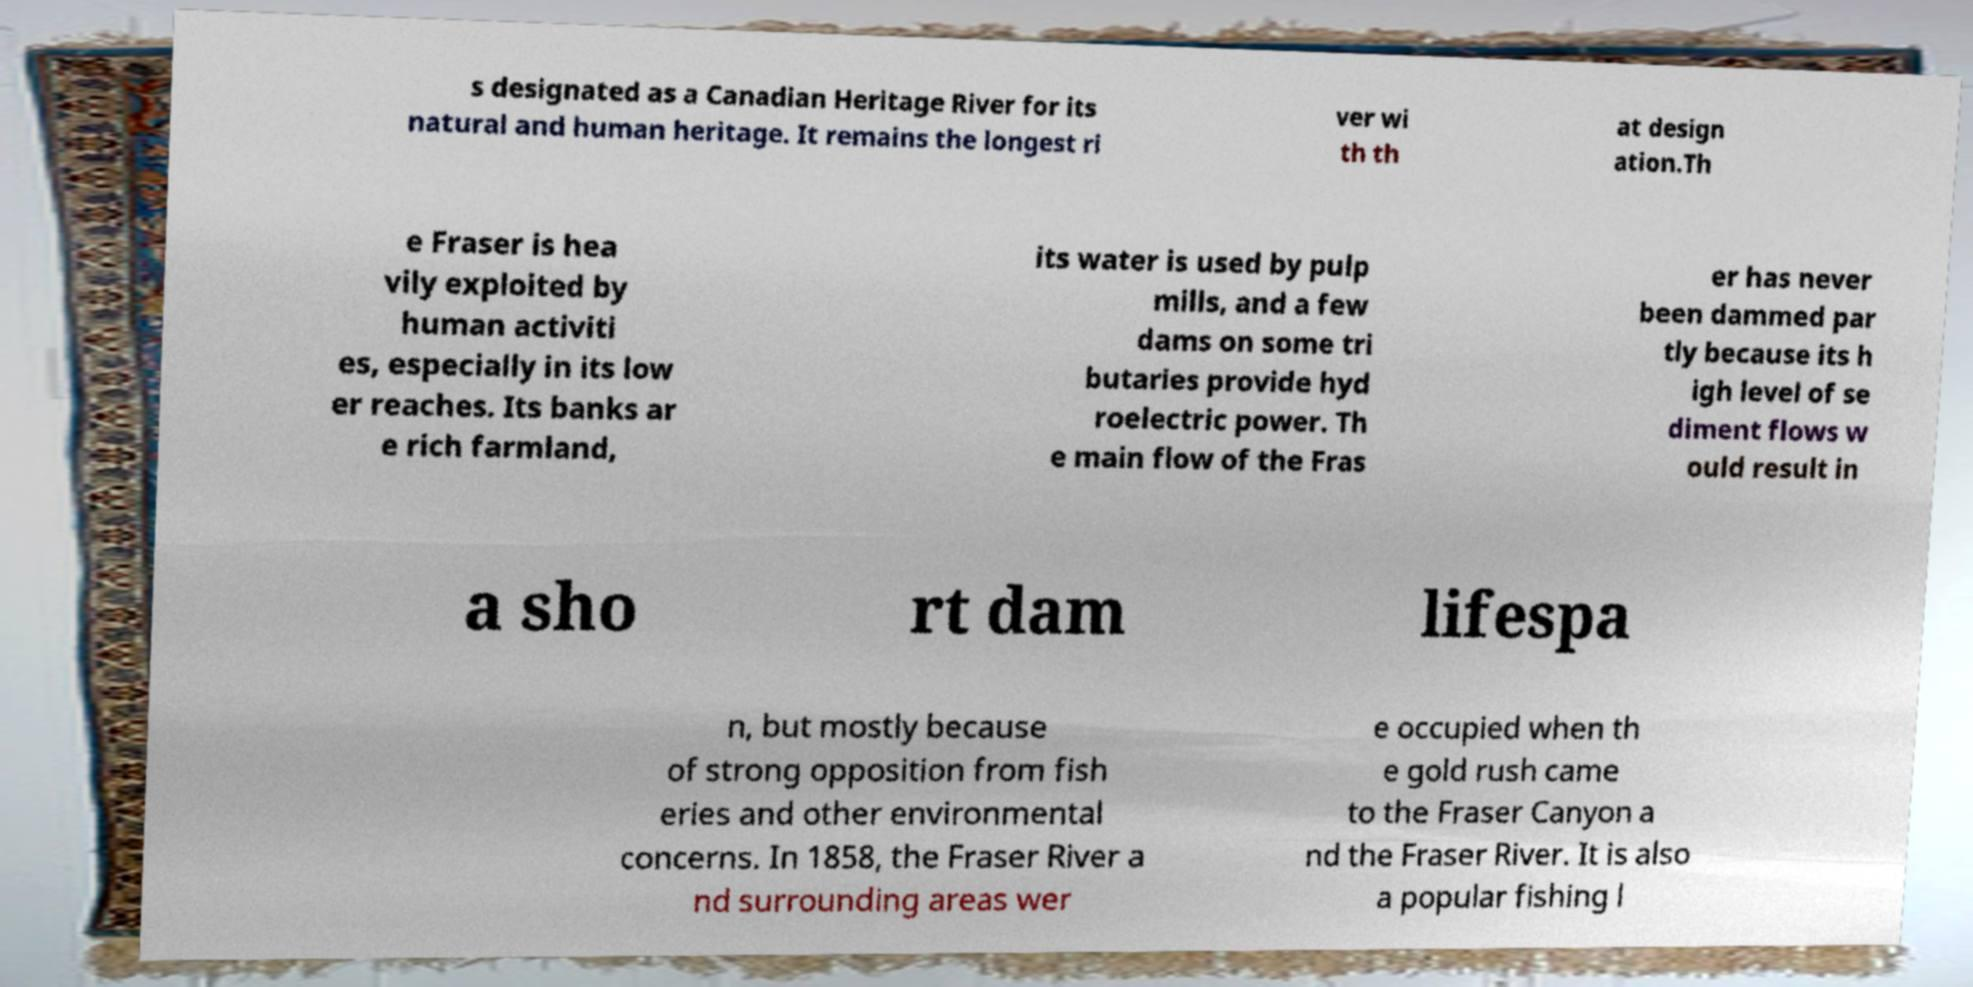Could you extract and type out the text from this image? s designated as a Canadian Heritage River for its natural and human heritage. It remains the longest ri ver wi th th at design ation.Th e Fraser is hea vily exploited by human activiti es, especially in its low er reaches. Its banks ar e rich farmland, its water is used by pulp mills, and a few dams on some tri butaries provide hyd roelectric power. Th e main flow of the Fras er has never been dammed par tly because its h igh level of se diment flows w ould result in a sho rt dam lifespa n, but mostly because of strong opposition from fish eries and other environmental concerns. In 1858, the Fraser River a nd surrounding areas wer e occupied when th e gold rush came to the Fraser Canyon a nd the Fraser River. It is also a popular fishing l 